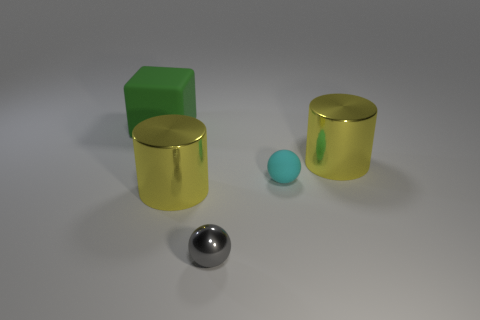There is a object that is to the right of the matte thing that is in front of the large green block; what color is it?
Offer a terse response. Yellow. Does the cyan rubber thing have the same size as the green rubber thing?
Give a very brief answer. No. Does the small thing that is on the right side of the small gray object have the same material as the large green object that is behind the small rubber ball?
Keep it short and to the point. Yes. There is a matte object in front of the green object to the left of the matte object that is in front of the block; what shape is it?
Your response must be concise. Sphere. Are there more big cubes than large red cylinders?
Give a very brief answer. Yes. Are any yellow objects visible?
Your response must be concise. Yes. What number of objects are either yellow shiny cylinders behind the tiny gray metallic ball or yellow objects that are left of the small cyan rubber thing?
Make the answer very short. 2. Is the number of tiny gray shiny things less than the number of big metal cylinders?
Give a very brief answer. Yes. Are there any yellow cylinders to the right of the green thing?
Give a very brief answer. Yes. Is the cyan object made of the same material as the big cube?
Your response must be concise. Yes. 